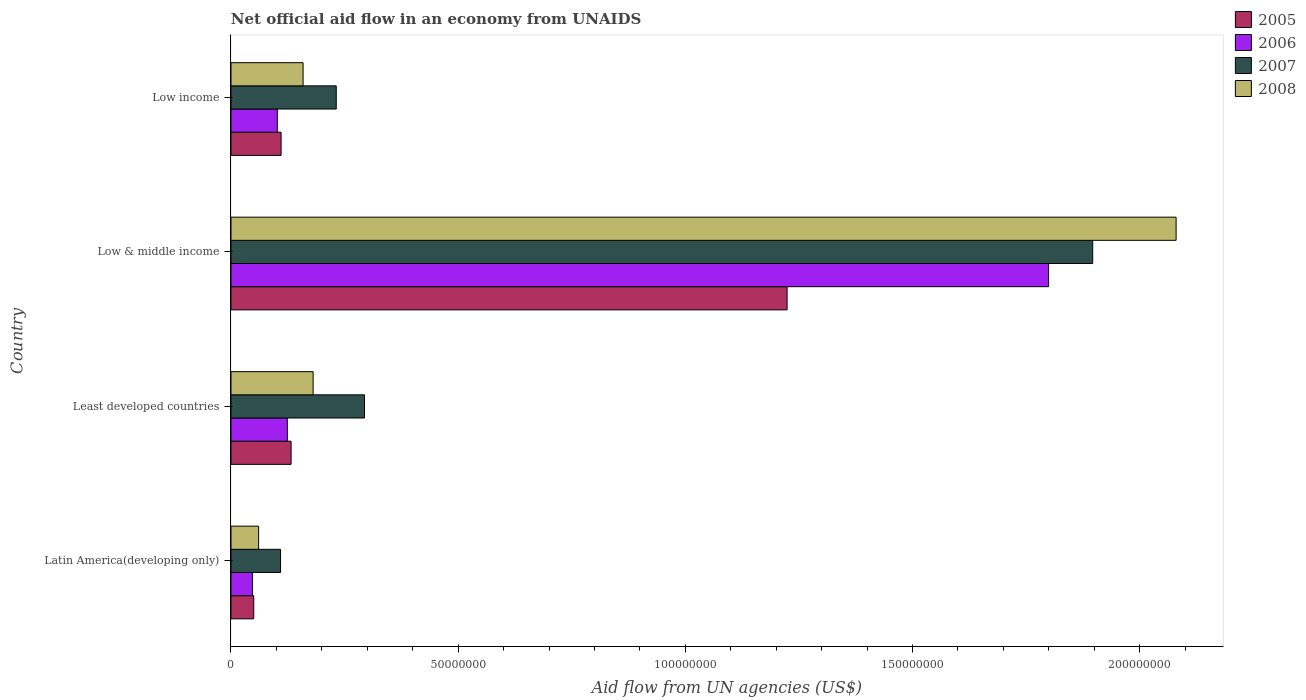Are the number of bars per tick equal to the number of legend labels?
Offer a very short reply. Yes. Are the number of bars on each tick of the Y-axis equal?
Your answer should be compact. Yes. What is the label of the 4th group of bars from the top?
Your response must be concise. Latin America(developing only). What is the net official aid flow in 2006 in Least developed countries?
Make the answer very short. 1.24e+07. Across all countries, what is the maximum net official aid flow in 2007?
Your answer should be compact. 1.90e+08. Across all countries, what is the minimum net official aid flow in 2005?
Provide a succinct answer. 5.01e+06. In which country was the net official aid flow in 2008 minimum?
Your response must be concise. Latin America(developing only). What is the total net official aid flow in 2007 in the graph?
Provide a short and direct response. 2.53e+08. What is the difference between the net official aid flow in 2007 in Least developed countries and that in Low & middle income?
Provide a short and direct response. -1.60e+08. What is the difference between the net official aid flow in 2008 in Least developed countries and the net official aid flow in 2005 in Low & middle income?
Your answer should be very brief. -1.04e+08. What is the average net official aid flow in 2007 per country?
Provide a succinct answer. 6.33e+07. What is the difference between the net official aid flow in 2006 and net official aid flow in 2008 in Least developed countries?
Provide a short and direct response. -5.68e+06. In how many countries, is the net official aid flow in 2005 greater than 60000000 US$?
Your answer should be very brief. 1. What is the ratio of the net official aid flow in 2006 in Low & middle income to that in Low income?
Provide a short and direct response. 17.64. Is the net official aid flow in 2006 in Low & middle income less than that in Low income?
Your answer should be compact. No. What is the difference between the highest and the second highest net official aid flow in 2007?
Offer a very short reply. 1.60e+08. What is the difference between the highest and the lowest net official aid flow in 2006?
Make the answer very short. 1.75e+08. In how many countries, is the net official aid flow in 2008 greater than the average net official aid flow in 2008 taken over all countries?
Provide a succinct answer. 1. Is the sum of the net official aid flow in 2007 in Least developed countries and Low & middle income greater than the maximum net official aid flow in 2006 across all countries?
Offer a very short reply. Yes. Is it the case that in every country, the sum of the net official aid flow in 2005 and net official aid flow in 2008 is greater than the sum of net official aid flow in 2007 and net official aid flow in 2006?
Give a very brief answer. No. What does the 2nd bar from the top in Low income represents?
Provide a short and direct response. 2007. What does the 2nd bar from the bottom in Low & middle income represents?
Ensure brevity in your answer.  2006. Where does the legend appear in the graph?
Make the answer very short. Top right. How are the legend labels stacked?
Give a very brief answer. Vertical. What is the title of the graph?
Your response must be concise. Net official aid flow in an economy from UNAIDS. What is the label or title of the X-axis?
Make the answer very short. Aid flow from UN agencies (US$). What is the label or title of the Y-axis?
Offer a very short reply. Country. What is the Aid flow from UN agencies (US$) of 2005 in Latin America(developing only)?
Offer a very short reply. 5.01e+06. What is the Aid flow from UN agencies (US$) in 2006 in Latin America(developing only)?
Give a very brief answer. 4.72e+06. What is the Aid flow from UN agencies (US$) of 2007 in Latin America(developing only)?
Ensure brevity in your answer.  1.09e+07. What is the Aid flow from UN agencies (US$) of 2008 in Latin America(developing only)?
Provide a succinct answer. 6.08e+06. What is the Aid flow from UN agencies (US$) of 2005 in Least developed countries?
Your response must be concise. 1.32e+07. What is the Aid flow from UN agencies (US$) of 2006 in Least developed countries?
Offer a very short reply. 1.24e+07. What is the Aid flow from UN agencies (US$) in 2007 in Least developed countries?
Your answer should be very brief. 2.94e+07. What is the Aid flow from UN agencies (US$) in 2008 in Least developed countries?
Make the answer very short. 1.81e+07. What is the Aid flow from UN agencies (US$) of 2005 in Low & middle income?
Your answer should be very brief. 1.22e+08. What is the Aid flow from UN agencies (US$) in 2006 in Low & middle income?
Give a very brief answer. 1.80e+08. What is the Aid flow from UN agencies (US$) of 2007 in Low & middle income?
Your answer should be very brief. 1.90e+08. What is the Aid flow from UN agencies (US$) of 2008 in Low & middle income?
Your answer should be compact. 2.08e+08. What is the Aid flow from UN agencies (US$) of 2005 in Low income?
Provide a succinct answer. 1.10e+07. What is the Aid flow from UN agencies (US$) of 2006 in Low income?
Offer a terse response. 1.02e+07. What is the Aid flow from UN agencies (US$) of 2007 in Low income?
Offer a very short reply. 2.32e+07. What is the Aid flow from UN agencies (US$) of 2008 in Low income?
Make the answer very short. 1.59e+07. Across all countries, what is the maximum Aid flow from UN agencies (US$) in 2005?
Give a very brief answer. 1.22e+08. Across all countries, what is the maximum Aid flow from UN agencies (US$) of 2006?
Make the answer very short. 1.80e+08. Across all countries, what is the maximum Aid flow from UN agencies (US$) of 2007?
Your answer should be very brief. 1.90e+08. Across all countries, what is the maximum Aid flow from UN agencies (US$) of 2008?
Your response must be concise. 2.08e+08. Across all countries, what is the minimum Aid flow from UN agencies (US$) of 2005?
Provide a succinct answer. 5.01e+06. Across all countries, what is the minimum Aid flow from UN agencies (US$) in 2006?
Keep it short and to the point. 4.72e+06. Across all countries, what is the minimum Aid flow from UN agencies (US$) in 2007?
Your answer should be very brief. 1.09e+07. Across all countries, what is the minimum Aid flow from UN agencies (US$) in 2008?
Offer a very short reply. 6.08e+06. What is the total Aid flow from UN agencies (US$) in 2005 in the graph?
Ensure brevity in your answer.  1.52e+08. What is the total Aid flow from UN agencies (US$) of 2006 in the graph?
Offer a terse response. 2.07e+08. What is the total Aid flow from UN agencies (US$) of 2007 in the graph?
Your answer should be very brief. 2.53e+08. What is the total Aid flow from UN agencies (US$) of 2008 in the graph?
Provide a succinct answer. 2.48e+08. What is the difference between the Aid flow from UN agencies (US$) of 2005 in Latin America(developing only) and that in Least developed countries?
Your answer should be very brief. -8.22e+06. What is the difference between the Aid flow from UN agencies (US$) of 2006 in Latin America(developing only) and that in Least developed countries?
Make the answer very short. -7.68e+06. What is the difference between the Aid flow from UN agencies (US$) of 2007 in Latin America(developing only) and that in Least developed countries?
Your answer should be very brief. -1.85e+07. What is the difference between the Aid flow from UN agencies (US$) of 2008 in Latin America(developing only) and that in Least developed countries?
Ensure brevity in your answer.  -1.20e+07. What is the difference between the Aid flow from UN agencies (US$) in 2005 in Latin America(developing only) and that in Low & middle income?
Your response must be concise. -1.17e+08. What is the difference between the Aid flow from UN agencies (US$) of 2006 in Latin America(developing only) and that in Low & middle income?
Provide a short and direct response. -1.75e+08. What is the difference between the Aid flow from UN agencies (US$) of 2007 in Latin America(developing only) and that in Low & middle income?
Your answer should be very brief. -1.79e+08. What is the difference between the Aid flow from UN agencies (US$) in 2008 in Latin America(developing only) and that in Low & middle income?
Your response must be concise. -2.02e+08. What is the difference between the Aid flow from UN agencies (US$) of 2005 in Latin America(developing only) and that in Low income?
Your response must be concise. -6.02e+06. What is the difference between the Aid flow from UN agencies (US$) of 2006 in Latin America(developing only) and that in Low income?
Provide a succinct answer. -5.48e+06. What is the difference between the Aid flow from UN agencies (US$) of 2007 in Latin America(developing only) and that in Low income?
Your answer should be compact. -1.23e+07. What is the difference between the Aid flow from UN agencies (US$) of 2008 in Latin America(developing only) and that in Low income?
Your answer should be very brief. -9.79e+06. What is the difference between the Aid flow from UN agencies (US$) of 2005 in Least developed countries and that in Low & middle income?
Your answer should be compact. -1.09e+08. What is the difference between the Aid flow from UN agencies (US$) of 2006 in Least developed countries and that in Low & middle income?
Keep it short and to the point. -1.68e+08. What is the difference between the Aid flow from UN agencies (US$) in 2007 in Least developed countries and that in Low & middle income?
Ensure brevity in your answer.  -1.60e+08. What is the difference between the Aid flow from UN agencies (US$) of 2008 in Least developed countries and that in Low & middle income?
Keep it short and to the point. -1.90e+08. What is the difference between the Aid flow from UN agencies (US$) in 2005 in Least developed countries and that in Low income?
Provide a succinct answer. 2.20e+06. What is the difference between the Aid flow from UN agencies (US$) in 2006 in Least developed countries and that in Low income?
Ensure brevity in your answer.  2.20e+06. What is the difference between the Aid flow from UN agencies (US$) in 2007 in Least developed countries and that in Low income?
Give a very brief answer. 6.22e+06. What is the difference between the Aid flow from UN agencies (US$) of 2008 in Least developed countries and that in Low income?
Offer a terse response. 2.21e+06. What is the difference between the Aid flow from UN agencies (US$) in 2005 in Low & middle income and that in Low income?
Keep it short and to the point. 1.11e+08. What is the difference between the Aid flow from UN agencies (US$) of 2006 in Low & middle income and that in Low income?
Your response must be concise. 1.70e+08. What is the difference between the Aid flow from UN agencies (US$) of 2007 in Low & middle income and that in Low income?
Give a very brief answer. 1.66e+08. What is the difference between the Aid flow from UN agencies (US$) in 2008 in Low & middle income and that in Low income?
Provide a succinct answer. 1.92e+08. What is the difference between the Aid flow from UN agencies (US$) in 2005 in Latin America(developing only) and the Aid flow from UN agencies (US$) in 2006 in Least developed countries?
Make the answer very short. -7.39e+06. What is the difference between the Aid flow from UN agencies (US$) in 2005 in Latin America(developing only) and the Aid flow from UN agencies (US$) in 2007 in Least developed countries?
Give a very brief answer. -2.44e+07. What is the difference between the Aid flow from UN agencies (US$) of 2005 in Latin America(developing only) and the Aid flow from UN agencies (US$) of 2008 in Least developed countries?
Give a very brief answer. -1.31e+07. What is the difference between the Aid flow from UN agencies (US$) of 2006 in Latin America(developing only) and the Aid flow from UN agencies (US$) of 2007 in Least developed countries?
Ensure brevity in your answer.  -2.47e+07. What is the difference between the Aid flow from UN agencies (US$) of 2006 in Latin America(developing only) and the Aid flow from UN agencies (US$) of 2008 in Least developed countries?
Ensure brevity in your answer.  -1.34e+07. What is the difference between the Aid flow from UN agencies (US$) of 2007 in Latin America(developing only) and the Aid flow from UN agencies (US$) of 2008 in Least developed countries?
Keep it short and to the point. -7.17e+06. What is the difference between the Aid flow from UN agencies (US$) of 2005 in Latin America(developing only) and the Aid flow from UN agencies (US$) of 2006 in Low & middle income?
Offer a terse response. -1.75e+08. What is the difference between the Aid flow from UN agencies (US$) in 2005 in Latin America(developing only) and the Aid flow from UN agencies (US$) in 2007 in Low & middle income?
Ensure brevity in your answer.  -1.85e+08. What is the difference between the Aid flow from UN agencies (US$) of 2005 in Latin America(developing only) and the Aid flow from UN agencies (US$) of 2008 in Low & middle income?
Your response must be concise. -2.03e+08. What is the difference between the Aid flow from UN agencies (US$) in 2006 in Latin America(developing only) and the Aid flow from UN agencies (US$) in 2007 in Low & middle income?
Provide a short and direct response. -1.85e+08. What is the difference between the Aid flow from UN agencies (US$) of 2006 in Latin America(developing only) and the Aid flow from UN agencies (US$) of 2008 in Low & middle income?
Provide a succinct answer. -2.03e+08. What is the difference between the Aid flow from UN agencies (US$) in 2007 in Latin America(developing only) and the Aid flow from UN agencies (US$) in 2008 in Low & middle income?
Your answer should be very brief. -1.97e+08. What is the difference between the Aid flow from UN agencies (US$) in 2005 in Latin America(developing only) and the Aid flow from UN agencies (US$) in 2006 in Low income?
Make the answer very short. -5.19e+06. What is the difference between the Aid flow from UN agencies (US$) in 2005 in Latin America(developing only) and the Aid flow from UN agencies (US$) in 2007 in Low income?
Give a very brief answer. -1.82e+07. What is the difference between the Aid flow from UN agencies (US$) of 2005 in Latin America(developing only) and the Aid flow from UN agencies (US$) of 2008 in Low income?
Make the answer very short. -1.09e+07. What is the difference between the Aid flow from UN agencies (US$) of 2006 in Latin America(developing only) and the Aid flow from UN agencies (US$) of 2007 in Low income?
Provide a short and direct response. -1.84e+07. What is the difference between the Aid flow from UN agencies (US$) of 2006 in Latin America(developing only) and the Aid flow from UN agencies (US$) of 2008 in Low income?
Your answer should be compact. -1.12e+07. What is the difference between the Aid flow from UN agencies (US$) of 2007 in Latin America(developing only) and the Aid flow from UN agencies (US$) of 2008 in Low income?
Offer a very short reply. -4.96e+06. What is the difference between the Aid flow from UN agencies (US$) of 2005 in Least developed countries and the Aid flow from UN agencies (US$) of 2006 in Low & middle income?
Offer a terse response. -1.67e+08. What is the difference between the Aid flow from UN agencies (US$) in 2005 in Least developed countries and the Aid flow from UN agencies (US$) in 2007 in Low & middle income?
Your answer should be compact. -1.76e+08. What is the difference between the Aid flow from UN agencies (US$) of 2005 in Least developed countries and the Aid flow from UN agencies (US$) of 2008 in Low & middle income?
Provide a short and direct response. -1.95e+08. What is the difference between the Aid flow from UN agencies (US$) in 2006 in Least developed countries and the Aid flow from UN agencies (US$) in 2007 in Low & middle income?
Make the answer very short. -1.77e+08. What is the difference between the Aid flow from UN agencies (US$) in 2006 in Least developed countries and the Aid flow from UN agencies (US$) in 2008 in Low & middle income?
Offer a terse response. -1.96e+08. What is the difference between the Aid flow from UN agencies (US$) in 2007 in Least developed countries and the Aid flow from UN agencies (US$) in 2008 in Low & middle income?
Ensure brevity in your answer.  -1.79e+08. What is the difference between the Aid flow from UN agencies (US$) in 2005 in Least developed countries and the Aid flow from UN agencies (US$) in 2006 in Low income?
Offer a terse response. 3.03e+06. What is the difference between the Aid flow from UN agencies (US$) in 2005 in Least developed countries and the Aid flow from UN agencies (US$) in 2007 in Low income?
Offer a terse response. -9.94e+06. What is the difference between the Aid flow from UN agencies (US$) in 2005 in Least developed countries and the Aid flow from UN agencies (US$) in 2008 in Low income?
Provide a succinct answer. -2.64e+06. What is the difference between the Aid flow from UN agencies (US$) of 2006 in Least developed countries and the Aid flow from UN agencies (US$) of 2007 in Low income?
Ensure brevity in your answer.  -1.08e+07. What is the difference between the Aid flow from UN agencies (US$) of 2006 in Least developed countries and the Aid flow from UN agencies (US$) of 2008 in Low income?
Ensure brevity in your answer.  -3.47e+06. What is the difference between the Aid flow from UN agencies (US$) in 2007 in Least developed countries and the Aid flow from UN agencies (US$) in 2008 in Low income?
Offer a terse response. 1.35e+07. What is the difference between the Aid flow from UN agencies (US$) of 2005 in Low & middle income and the Aid flow from UN agencies (US$) of 2006 in Low income?
Your answer should be very brief. 1.12e+08. What is the difference between the Aid flow from UN agencies (US$) of 2005 in Low & middle income and the Aid flow from UN agencies (US$) of 2007 in Low income?
Offer a terse response. 9.92e+07. What is the difference between the Aid flow from UN agencies (US$) in 2005 in Low & middle income and the Aid flow from UN agencies (US$) in 2008 in Low income?
Offer a terse response. 1.07e+08. What is the difference between the Aid flow from UN agencies (US$) in 2006 in Low & middle income and the Aid flow from UN agencies (US$) in 2007 in Low income?
Your response must be concise. 1.57e+08. What is the difference between the Aid flow from UN agencies (US$) of 2006 in Low & middle income and the Aid flow from UN agencies (US$) of 2008 in Low income?
Provide a succinct answer. 1.64e+08. What is the difference between the Aid flow from UN agencies (US$) in 2007 in Low & middle income and the Aid flow from UN agencies (US$) in 2008 in Low income?
Your answer should be compact. 1.74e+08. What is the average Aid flow from UN agencies (US$) of 2005 per country?
Make the answer very short. 3.79e+07. What is the average Aid flow from UN agencies (US$) in 2006 per country?
Your answer should be very brief. 5.18e+07. What is the average Aid flow from UN agencies (US$) in 2007 per country?
Provide a short and direct response. 6.33e+07. What is the average Aid flow from UN agencies (US$) in 2008 per country?
Offer a terse response. 6.20e+07. What is the difference between the Aid flow from UN agencies (US$) in 2005 and Aid flow from UN agencies (US$) in 2006 in Latin America(developing only)?
Offer a very short reply. 2.90e+05. What is the difference between the Aid flow from UN agencies (US$) of 2005 and Aid flow from UN agencies (US$) of 2007 in Latin America(developing only)?
Ensure brevity in your answer.  -5.90e+06. What is the difference between the Aid flow from UN agencies (US$) in 2005 and Aid flow from UN agencies (US$) in 2008 in Latin America(developing only)?
Keep it short and to the point. -1.07e+06. What is the difference between the Aid flow from UN agencies (US$) of 2006 and Aid flow from UN agencies (US$) of 2007 in Latin America(developing only)?
Your answer should be very brief. -6.19e+06. What is the difference between the Aid flow from UN agencies (US$) of 2006 and Aid flow from UN agencies (US$) of 2008 in Latin America(developing only)?
Offer a very short reply. -1.36e+06. What is the difference between the Aid flow from UN agencies (US$) in 2007 and Aid flow from UN agencies (US$) in 2008 in Latin America(developing only)?
Your answer should be compact. 4.83e+06. What is the difference between the Aid flow from UN agencies (US$) of 2005 and Aid flow from UN agencies (US$) of 2006 in Least developed countries?
Your response must be concise. 8.30e+05. What is the difference between the Aid flow from UN agencies (US$) of 2005 and Aid flow from UN agencies (US$) of 2007 in Least developed countries?
Provide a short and direct response. -1.62e+07. What is the difference between the Aid flow from UN agencies (US$) in 2005 and Aid flow from UN agencies (US$) in 2008 in Least developed countries?
Give a very brief answer. -4.85e+06. What is the difference between the Aid flow from UN agencies (US$) in 2006 and Aid flow from UN agencies (US$) in 2007 in Least developed countries?
Offer a terse response. -1.70e+07. What is the difference between the Aid flow from UN agencies (US$) of 2006 and Aid flow from UN agencies (US$) of 2008 in Least developed countries?
Provide a succinct answer. -5.68e+06. What is the difference between the Aid flow from UN agencies (US$) of 2007 and Aid flow from UN agencies (US$) of 2008 in Least developed countries?
Offer a terse response. 1.13e+07. What is the difference between the Aid flow from UN agencies (US$) in 2005 and Aid flow from UN agencies (US$) in 2006 in Low & middle income?
Ensure brevity in your answer.  -5.76e+07. What is the difference between the Aid flow from UN agencies (US$) in 2005 and Aid flow from UN agencies (US$) in 2007 in Low & middle income?
Your response must be concise. -6.73e+07. What is the difference between the Aid flow from UN agencies (US$) of 2005 and Aid flow from UN agencies (US$) of 2008 in Low & middle income?
Your answer should be compact. -8.56e+07. What is the difference between the Aid flow from UN agencies (US$) of 2006 and Aid flow from UN agencies (US$) of 2007 in Low & middle income?
Your answer should be compact. -9.71e+06. What is the difference between the Aid flow from UN agencies (US$) of 2006 and Aid flow from UN agencies (US$) of 2008 in Low & middle income?
Offer a terse response. -2.81e+07. What is the difference between the Aid flow from UN agencies (US$) in 2007 and Aid flow from UN agencies (US$) in 2008 in Low & middle income?
Give a very brief answer. -1.84e+07. What is the difference between the Aid flow from UN agencies (US$) of 2005 and Aid flow from UN agencies (US$) of 2006 in Low income?
Your answer should be compact. 8.30e+05. What is the difference between the Aid flow from UN agencies (US$) of 2005 and Aid flow from UN agencies (US$) of 2007 in Low income?
Offer a terse response. -1.21e+07. What is the difference between the Aid flow from UN agencies (US$) of 2005 and Aid flow from UN agencies (US$) of 2008 in Low income?
Ensure brevity in your answer.  -4.84e+06. What is the difference between the Aid flow from UN agencies (US$) of 2006 and Aid flow from UN agencies (US$) of 2007 in Low income?
Offer a very short reply. -1.30e+07. What is the difference between the Aid flow from UN agencies (US$) of 2006 and Aid flow from UN agencies (US$) of 2008 in Low income?
Offer a very short reply. -5.67e+06. What is the difference between the Aid flow from UN agencies (US$) of 2007 and Aid flow from UN agencies (US$) of 2008 in Low income?
Provide a short and direct response. 7.30e+06. What is the ratio of the Aid flow from UN agencies (US$) of 2005 in Latin America(developing only) to that in Least developed countries?
Your response must be concise. 0.38. What is the ratio of the Aid flow from UN agencies (US$) of 2006 in Latin America(developing only) to that in Least developed countries?
Your response must be concise. 0.38. What is the ratio of the Aid flow from UN agencies (US$) of 2007 in Latin America(developing only) to that in Least developed countries?
Make the answer very short. 0.37. What is the ratio of the Aid flow from UN agencies (US$) in 2008 in Latin America(developing only) to that in Least developed countries?
Your response must be concise. 0.34. What is the ratio of the Aid flow from UN agencies (US$) in 2005 in Latin America(developing only) to that in Low & middle income?
Offer a terse response. 0.04. What is the ratio of the Aid flow from UN agencies (US$) of 2006 in Latin America(developing only) to that in Low & middle income?
Provide a succinct answer. 0.03. What is the ratio of the Aid flow from UN agencies (US$) in 2007 in Latin America(developing only) to that in Low & middle income?
Ensure brevity in your answer.  0.06. What is the ratio of the Aid flow from UN agencies (US$) of 2008 in Latin America(developing only) to that in Low & middle income?
Your response must be concise. 0.03. What is the ratio of the Aid flow from UN agencies (US$) in 2005 in Latin America(developing only) to that in Low income?
Provide a short and direct response. 0.45. What is the ratio of the Aid flow from UN agencies (US$) of 2006 in Latin America(developing only) to that in Low income?
Provide a short and direct response. 0.46. What is the ratio of the Aid flow from UN agencies (US$) of 2007 in Latin America(developing only) to that in Low income?
Your response must be concise. 0.47. What is the ratio of the Aid flow from UN agencies (US$) in 2008 in Latin America(developing only) to that in Low income?
Offer a very short reply. 0.38. What is the ratio of the Aid flow from UN agencies (US$) in 2005 in Least developed countries to that in Low & middle income?
Your answer should be compact. 0.11. What is the ratio of the Aid flow from UN agencies (US$) in 2006 in Least developed countries to that in Low & middle income?
Give a very brief answer. 0.07. What is the ratio of the Aid flow from UN agencies (US$) of 2007 in Least developed countries to that in Low & middle income?
Offer a very short reply. 0.15. What is the ratio of the Aid flow from UN agencies (US$) in 2008 in Least developed countries to that in Low & middle income?
Ensure brevity in your answer.  0.09. What is the ratio of the Aid flow from UN agencies (US$) of 2005 in Least developed countries to that in Low income?
Keep it short and to the point. 1.2. What is the ratio of the Aid flow from UN agencies (US$) of 2006 in Least developed countries to that in Low income?
Give a very brief answer. 1.22. What is the ratio of the Aid flow from UN agencies (US$) of 2007 in Least developed countries to that in Low income?
Give a very brief answer. 1.27. What is the ratio of the Aid flow from UN agencies (US$) in 2008 in Least developed countries to that in Low income?
Your answer should be compact. 1.14. What is the ratio of the Aid flow from UN agencies (US$) of 2005 in Low & middle income to that in Low income?
Offer a very short reply. 11.1. What is the ratio of the Aid flow from UN agencies (US$) in 2006 in Low & middle income to that in Low income?
Your answer should be very brief. 17.64. What is the ratio of the Aid flow from UN agencies (US$) of 2007 in Low & middle income to that in Low income?
Your response must be concise. 8.19. What is the ratio of the Aid flow from UN agencies (US$) of 2008 in Low & middle income to that in Low income?
Your answer should be compact. 13.11. What is the difference between the highest and the second highest Aid flow from UN agencies (US$) in 2005?
Your answer should be very brief. 1.09e+08. What is the difference between the highest and the second highest Aid flow from UN agencies (US$) in 2006?
Ensure brevity in your answer.  1.68e+08. What is the difference between the highest and the second highest Aid flow from UN agencies (US$) of 2007?
Your response must be concise. 1.60e+08. What is the difference between the highest and the second highest Aid flow from UN agencies (US$) in 2008?
Your answer should be very brief. 1.90e+08. What is the difference between the highest and the lowest Aid flow from UN agencies (US$) of 2005?
Your answer should be very brief. 1.17e+08. What is the difference between the highest and the lowest Aid flow from UN agencies (US$) in 2006?
Your answer should be very brief. 1.75e+08. What is the difference between the highest and the lowest Aid flow from UN agencies (US$) of 2007?
Provide a succinct answer. 1.79e+08. What is the difference between the highest and the lowest Aid flow from UN agencies (US$) in 2008?
Ensure brevity in your answer.  2.02e+08. 